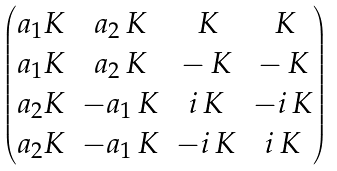Convert formula to latex. <formula><loc_0><loc_0><loc_500><loc_500>\begin{pmatrix} a _ { 1 } K & a _ { 2 } \, K & \, K & \, K \\ a _ { 1 } K & a _ { 2 } \, K & - \, K & - \, K \\ a _ { 2 } K & - a _ { 1 } \, K & i \, K & - i \, K \\ a _ { 2 } K & - a _ { 1 } \, K & - i \, K & i \, K \end{pmatrix}</formula> 